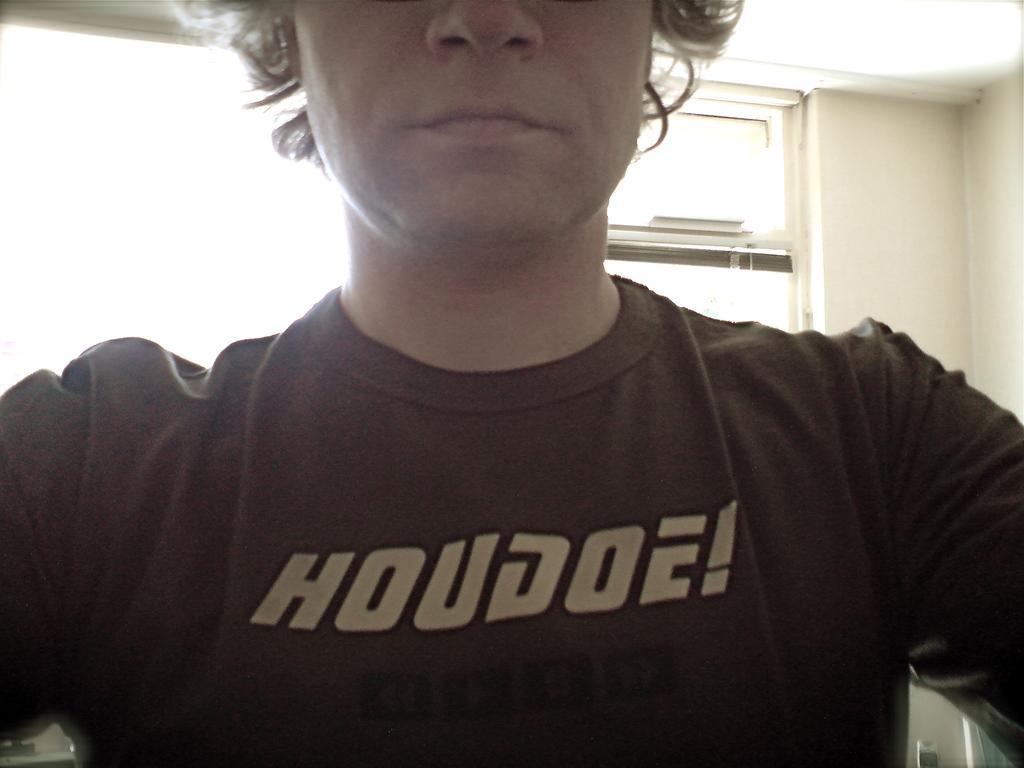How would you summarize this image in a sentence or two? In this picture I can see a person, and in the background there is a window and a wall. 